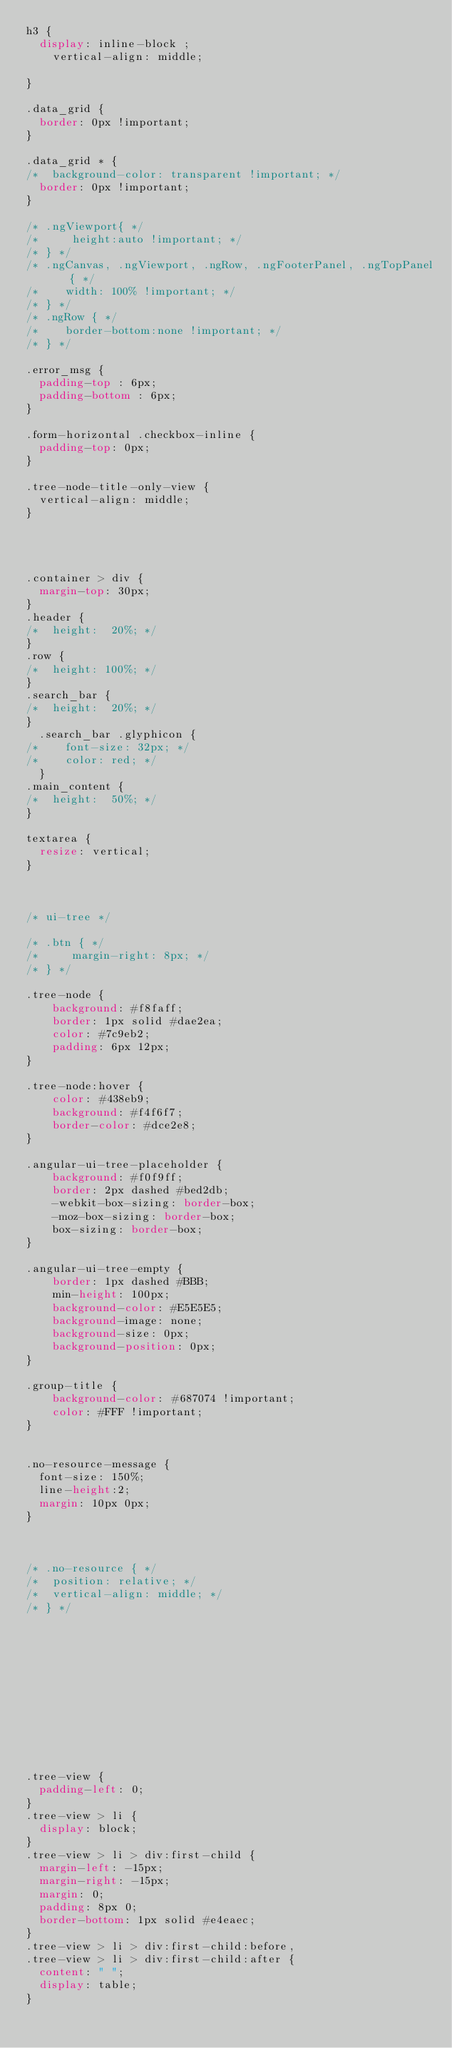Convert code to text. <code><loc_0><loc_0><loc_500><loc_500><_CSS_>h3 {
	display: inline-block ;
    vertical-align: middle;

}

.data_grid {
	border: 0px !important;
}

.data_grid * {
/* 	background-color: transparent !important; */
	border: 0px !important;
}

/* .ngViewport{ */
/*     height:auto !important; */
/* } */
/* .ngCanvas, .ngViewport, .ngRow, .ngFooterPanel, .ngTopPanel   { */
/*    width: 100% !important; */
/* } */
/* .ngRow { */
/*    border-bottom:none !important; */
/* } */

.error_msg {
	padding-top : 6px;
	padding-bottom : 6px;
}

.form-horizontal .checkbox-inline {
	padding-top: 0px;
}

.tree-node-title-only-view {
	vertical-align: middle;
}




.container > div {
	margin-top: 30px;
}
.header {
/* 	height:  20%; */
}
.row {
/* 	height: 100%; */
}
.search_bar {
/* 	height:  20%; */
}
	.search_bar .glyphicon {
/* 		font-size: 32px; */
/* 		color: red; */
	}
.main_content {
/* 	height:  50%; */
}

textarea {
	resize: vertical;
}



/* ui-tree */

/* .btn { */
/*     margin-right: 8px; */
/* } */

.tree-node {
    background: #f8faff;
    border: 1px solid #dae2ea;
    color: #7c9eb2;
    padding: 6px 12px;
}

.tree-node:hover {
    color: #438eb9;
    background: #f4f6f7;
    border-color: #dce2e8;
}

.angular-ui-tree-placeholder {
    background: #f0f9ff;
    border: 2px dashed #bed2db;
    -webkit-box-sizing: border-box;
    -moz-box-sizing: border-box;
    box-sizing: border-box;
}

.angular-ui-tree-empty {
    border: 1px dashed #BBB;
    min-height: 100px;
    background-color: #E5E5E5;
    background-image: none;
    background-size: 0px;
    background-position: 0px;
}

.group-title {
    background-color: #687074 !important;
    color: #FFF !important;
}


.no-resource-message {
	font-size: 150%;
	line-height:2;
	margin: 10px 0px;
}



/* .no-resource { */
/*  position: relative; */
/*  vertical-align: middle; */
/* } */












.tree-view {
  padding-left: 0;
}
.tree-view > li {
  display: block;
}
.tree-view > li > div:first-child {
  margin-left: -15px;
  margin-right: -15px;
  margin: 0;
  padding: 8px 0;
  border-bottom: 1px solid #e4eaec;
}
.tree-view > li > div:first-child:before,
.tree-view > li > div:first-child:after {
  content: " ";
  display: table;
}</code> 